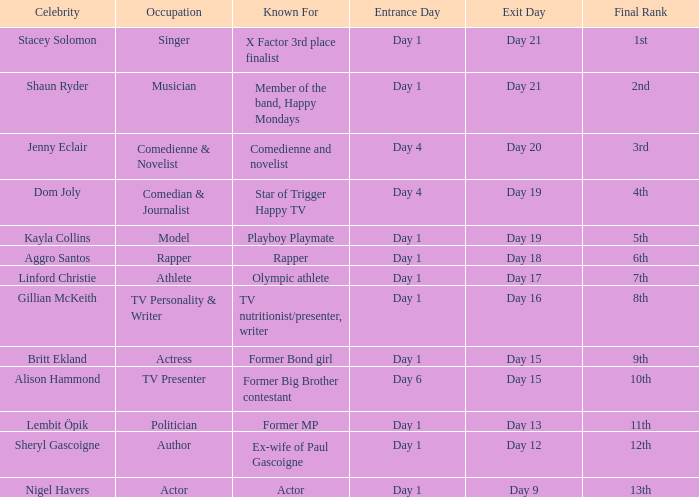What was Dom Joly famous for? Comedian, journalist and star of Trigger Happy TV. 